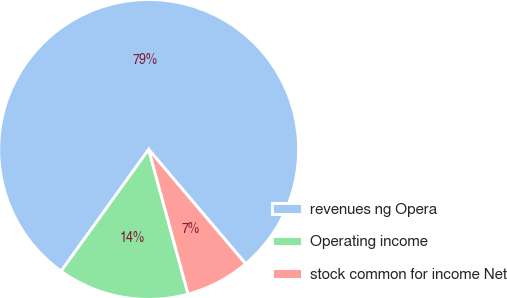Convert chart to OTSL. <chart><loc_0><loc_0><loc_500><loc_500><pie_chart><fcel>revenues ng Opera<fcel>Operating income<fcel>stock common for income Net<nl><fcel>78.88%<fcel>14.16%<fcel>6.96%<nl></chart> 